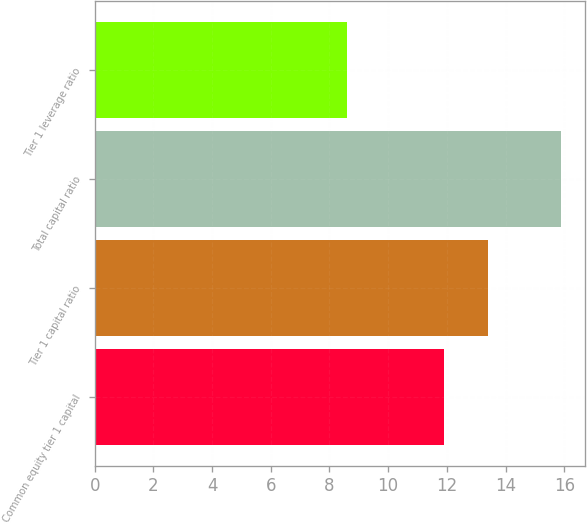Convert chart to OTSL. <chart><loc_0><loc_0><loc_500><loc_500><bar_chart><fcel>Common equity tier 1 capital<fcel>Tier 1 capital ratio<fcel>Total capital ratio<fcel>Tier 1 leverage ratio<nl><fcel>11.9<fcel>13.4<fcel>15.9<fcel>8.6<nl></chart> 